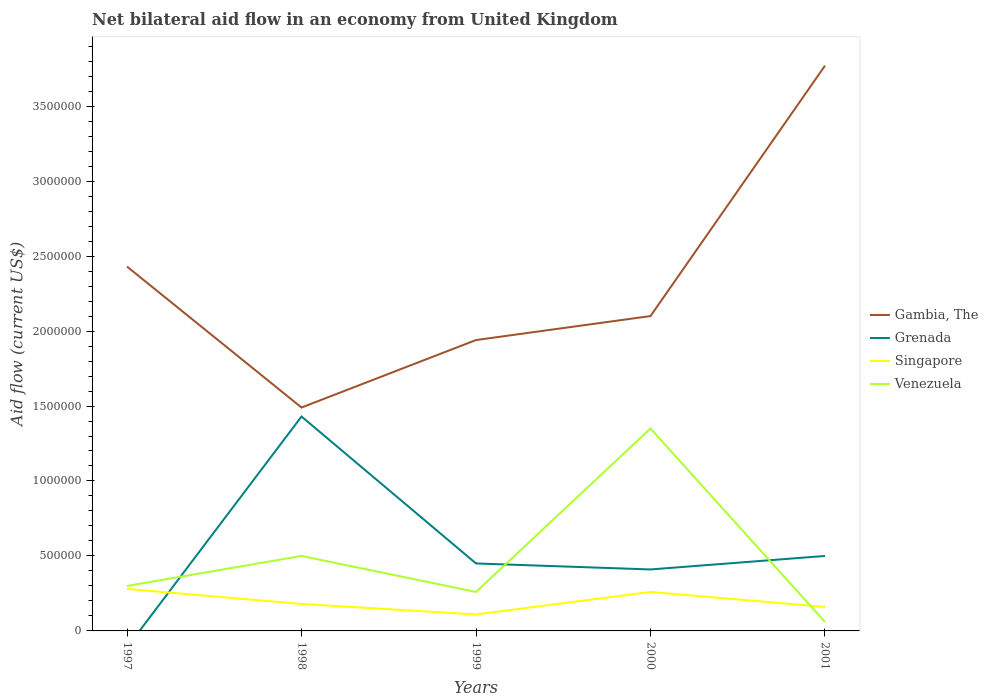Does the line corresponding to Singapore intersect with the line corresponding to Venezuela?
Your response must be concise. Yes. Is the number of lines equal to the number of legend labels?
Provide a short and direct response. No. What is the difference between the highest and the second highest net bilateral aid flow in Grenada?
Your response must be concise. 1.43e+06. Is the net bilateral aid flow in Grenada strictly greater than the net bilateral aid flow in Venezuela over the years?
Provide a short and direct response. No. How many lines are there?
Keep it short and to the point. 4. Does the graph contain any zero values?
Offer a very short reply. Yes. What is the title of the graph?
Offer a terse response. Net bilateral aid flow in an economy from United Kingdom. What is the label or title of the Y-axis?
Keep it short and to the point. Aid flow (current US$). What is the Aid flow (current US$) of Gambia, The in 1997?
Your answer should be very brief. 2.43e+06. What is the Aid flow (current US$) in Grenada in 1997?
Make the answer very short. 0. What is the Aid flow (current US$) in Venezuela in 1997?
Your answer should be very brief. 3.00e+05. What is the Aid flow (current US$) in Gambia, The in 1998?
Offer a very short reply. 1.49e+06. What is the Aid flow (current US$) in Grenada in 1998?
Provide a succinct answer. 1.43e+06. What is the Aid flow (current US$) of Gambia, The in 1999?
Your response must be concise. 1.94e+06. What is the Aid flow (current US$) of Singapore in 1999?
Offer a terse response. 1.10e+05. What is the Aid flow (current US$) in Venezuela in 1999?
Provide a short and direct response. 2.60e+05. What is the Aid flow (current US$) of Gambia, The in 2000?
Keep it short and to the point. 2.10e+06. What is the Aid flow (current US$) of Singapore in 2000?
Your answer should be compact. 2.60e+05. What is the Aid flow (current US$) of Venezuela in 2000?
Give a very brief answer. 1.35e+06. What is the Aid flow (current US$) of Gambia, The in 2001?
Make the answer very short. 3.77e+06. What is the Aid flow (current US$) of Singapore in 2001?
Offer a very short reply. 1.60e+05. Across all years, what is the maximum Aid flow (current US$) in Gambia, The?
Your response must be concise. 3.77e+06. Across all years, what is the maximum Aid flow (current US$) in Grenada?
Provide a short and direct response. 1.43e+06. Across all years, what is the maximum Aid flow (current US$) of Singapore?
Offer a terse response. 2.80e+05. Across all years, what is the maximum Aid flow (current US$) in Venezuela?
Ensure brevity in your answer.  1.35e+06. Across all years, what is the minimum Aid flow (current US$) in Gambia, The?
Your answer should be compact. 1.49e+06. Across all years, what is the minimum Aid flow (current US$) in Grenada?
Give a very brief answer. 0. Across all years, what is the minimum Aid flow (current US$) in Singapore?
Your answer should be compact. 1.10e+05. What is the total Aid flow (current US$) in Gambia, The in the graph?
Make the answer very short. 1.17e+07. What is the total Aid flow (current US$) in Grenada in the graph?
Keep it short and to the point. 2.79e+06. What is the total Aid flow (current US$) of Singapore in the graph?
Your answer should be very brief. 9.90e+05. What is the total Aid flow (current US$) of Venezuela in the graph?
Offer a terse response. 2.47e+06. What is the difference between the Aid flow (current US$) of Gambia, The in 1997 and that in 1998?
Your answer should be very brief. 9.40e+05. What is the difference between the Aid flow (current US$) in Gambia, The in 1997 and that in 1999?
Provide a short and direct response. 4.90e+05. What is the difference between the Aid flow (current US$) in Singapore in 1997 and that in 2000?
Make the answer very short. 2.00e+04. What is the difference between the Aid flow (current US$) of Venezuela in 1997 and that in 2000?
Offer a terse response. -1.05e+06. What is the difference between the Aid flow (current US$) of Gambia, The in 1997 and that in 2001?
Keep it short and to the point. -1.34e+06. What is the difference between the Aid flow (current US$) in Gambia, The in 1998 and that in 1999?
Keep it short and to the point. -4.50e+05. What is the difference between the Aid flow (current US$) in Grenada in 1998 and that in 1999?
Your answer should be compact. 9.80e+05. What is the difference between the Aid flow (current US$) of Singapore in 1998 and that in 1999?
Give a very brief answer. 7.00e+04. What is the difference between the Aid flow (current US$) in Gambia, The in 1998 and that in 2000?
Your response must be concise. -6.10e+05. What is the difference between the Aid flow (current US$) in Grenada in 1998 and that in 2000?
Provide a succinct answer. 1.02e+06. What is the difference between the Aid flow (current US$) in Singapore in 1998 and that in 2000?
Your answer should be compact. -8.00e+04. What is the difference between the Aid flow (current US$) in Venezuela in 1998 and that in 2000?
Ensure brevity in your answer.  -8.50e+05. What is the difference between the Aid flow (current US$) in Gambia, The in 1998 and that in 2001?
Give a very brief answer. -2.28e+06. What is the difference between the Aid flow (current US$) in Grenada in 1998 and that in 2001?
Provide a succinct answer. 9.30e+05. What is the difference between the Aid flow (current US$) of Venezuela in 1998 and that in 2001?
Give a very brief answer. 4.40e+05. What is the difference between the Aid flow (current US$) in Venezuela in 1999 and that in 2000?
Offer a terse response. -1.09e+06. What is the difference between the Aid flow (current US$) of Gambia, The in 1999 and that in 2001?
Offer a terse response. -1.83e+06. What is the difference between the Aid flow (current US$) in Venezuela in 1999 and that in 2001?
Make the answer very short. 2.00e+05. What is the difference between the Aid flow (current US$) of Gambia, The in 2000 and that in 2001?
Keep it short and to the point. -1.67e+06. What is the difference between the Aid flow (current US$) in Singapore in 2000 and that in 2001?
Ensure brevity in your answer.  1.00e+05. What is the difference between the Aid flow (current US$) in Venezuela in 2000 and that in 2001?
Offer a very short reply. 1.29e+06. What is the difference between the Aid flow (current US$) of Gambia, The in 1997 and the Aid flow (current US$) of Grenada in 1998?
Offer a terse response. 1.00e+06. What is the difference between the Aid flow (current US$) in Gambia, The in 1997 and the Aid flow (current US$) in Singapore in 1998?
Offer a terse response. 2.25e+06. What is the difference between the Aid flow (current US$) of Gambia, The in 1997 and the Aid flow (current US$) of Venezuela in 1998?
Keep it short and to the point. 1.93e+06. What is the difference between the Aid flow (current US$) in Gambia, The in 1997 and the Aid flow (current US$) in Grenada in 1999?
Your answer should be very brief. 1.98e+06. What is the difference between the Aid flow (current US$) of Gambia, The in 1997 and the Aid flow (current US$) of Singapore in 1999?
Offer a very short reply. 2.32e+06. What is the difference between the Aid flow (current US$) in Gambia, The in 1997 and the Aid flow (current US$) in Venezuela in 1999?
Your answer should be compact. 2.17e+06. What is the difference between the Aid flow (current US$) of Gambia, The in 1997 and the Aid flow (current US$) of Grenada in 2000?
Make the answer very short. 2.02e+06. What is the difference between the Aid flow (current US$) of Gambia, The in 1997 and the Aid flow (current US$) of Singapore in 2000?
Your response must be concise. 2.17e+06. What is the difference between the Aid flow (current US$) of Gambia, The in 1997 and the Aid flow (current US$) of Venezuela in 2000?
Offer a very short reply. 1.08e+06. What is the difference between the Aid flow (current US$) in Singapore in 1997 and the Aid flow (current US$) in Venezuela in 2000?
Your response must be concise. -1.07e+06. What is the difference between the Aid flow (current US$) in Gambia, The in 1997 and the Aid flow (current US$) in Grenada in 2001?
Ensure brevity in your answer.  1.93e+06. What is the difference between the Aid flow (current US$) of Gambia, The in 1997 and the Aid flow (current US$) of Singapore in 2001?
Offer a terse response. 2.27e+06. What is the difference between the Aid flow (current US$) of Gambia, The in 1997 and the Aid flow (current US$) of Venezuela in 2001?
Your answer should be compact. 2.37e+06. What is the difference between the Aid flow (current US$) in Singapore in 1997 and the Aid flow (current US$) in Venezuela in 2001?
Offer a terse response. 2.20e+05. What is the difference between the Aid flow (current US$) of Gambia, The in 1998 and the Aid flow (current US$) of Grenada in 1999?
Your response must be concise. 1.04e+06. What is the difference between the Aid flow (current US$) in Gambia, The in 1998 and the Aid flow (current US$) in Singapore in 1999?
Provide a succinct answer. 1.38e+06. What is the difference between the Aid flow (current US$) in Gambia, The in 1998 and the Aid flow (current US$) in Venezuela in 1999?
Your answer should be very brief. 1.23e+06. What is the difference between the Aid flow (current US$) in Grenada in 1998 and the Aid flow (current US$) in Singapore in 1999?
Provide a short and direct response. 1.32e+06. What is the difference between the Aid flow (current US$) in Grenada in 1998 and the Aid flow (current US$) in Venezuela in 1999?
Your answer should be compact. 1.17e+06. What is the difference between the Aid flow (current US$) of Singapore in 1998 and the Aid flow (current US$) of Venezuela in 1999?
Provide a short and direct response. -8.00e+04. What is the difference between the Aid flow (current US$) of Gambia, The in 1998 and the Aid flow (current US$) of Grenada in 2000?
Ensure brevity in your answer.  1.08e+06. What is the difference between the Aid flow (current US$) in Gambia, The in 1998 and the Aid flow (current US$) in Singapore in 2000?
Ensure brevity in your answer.  1.23e+06. What is the difference between the Aid flow (current US$) in Grenada in 1998 and the Aid flow (current US$) in Singapore in 2000?
Offer a terse response. 1.17e+06. What is the difference between the Aid flow (current US$) of Grenada in 1998 and the Aid flow (current US$) of Venezuela in 2000?
Offer a terse response. 8.00e+04. What is the difference between the Aid flow (current US$) of Singapore in 1998 and the Aid flow (current US$) of Venezuela in 2000?
Make the answer very short. -1.17e+06. What is the difference between the Aid flow (current US$) in Gambia, The in 1998 and the Aid flow (current US$) in Grenada in 2001?
Make the answer very short. 9.90e+05. What is the difference between the Aid flow (current US$) in Gambia, The in 1998 and the Aid flow (current US$) in Singapore in 2001?
Your answer should be compact. 1.33e+06. What is the difference between the Aid flow (current US$) in Gambia, The in 1998 and the Aid flow (current US$) in Venezuela in 2001?
Keep it short and to the point. 1.43e+06. What is the difference between the Aid flow (current US$) of Grenada in 1998 and the Aid flow (current US$) of Singapore in 2001?
Your response must be concise. 1.27e+06. What is the difference between the Aid flow (current US$) in Grenada in 1998 and the Aid flow (current US$) in Venezuela in 2001?
Make the answer very short. 1.37e+06. What is the difference between the Aid flow (current US$) of Gambia, The in 1999 and the Aid flow (current US$) of Grenada in 2000?
Your response must be concise. 1.53e+06. What is the difference between the Aid flow (current US$) of Gambia, The in 1999 and the Aid flow (current US$) of Singapore in 2000?
Provide a succinct answer. 1.68e+06. What is the difference between the Aid flow (current US$) in Gambia, The in 1999 and the Aid flow (current US$) in Venezuela in 2000?
Keep it short and to the point. 5.90e+05. What is the difference between the Aid flow (current US$) in Grenada in 1999 and the Aid flow (current US$) in Venezuela in 2000?
Offer a terse response. -9.00e+05. What is the difference between the Aid flow (current US$) of Singapore in 1999 and the Aid flow (current US$) of Venezuela in 2000?
Your answer should be compact. -1.24e+06. What is the difference between the Aid flow (current US$) of Gambia, The in 1999 and the Aid flow (current US$) of Grenada in 2001?
Your answer should be compact. 1.44e+06. What is the difference between the Aid flow (current US$) of Gambia, The in 1999 and the Aid flow (current US$) of Singapore in 2001?
Provide a succinct answer. 1.78e+06. What is the difference between the Aid flow (current US$) of Gambia, The in 1999 and the Aid flow (current US$) of Venezuela in 2001?
Your answer should be very brief. 1.88e+06. What is the difference between the Aid flow (current US$) in Grenada in 1999 and the Aid flow (current US$) in Singapore in 2001?
Give a very brief answer. 2.90e+05. What is the difference between the Aid flow (current US$) in Grenada in 1999 and the Aid flow (current US$) in Venezuela in 2001?
Provide a succinct answer. 3.90e+05. What is the difference between the Aid flow (current US$) in Gambia, The in 2000 and the Aid flow (current US$) in Grenada in 2001?
Give a very brief answer. 1.60e+06. What is the difference between the Aid flow (current US$) of Gambia, The in 2000 and the Aid flow (current US$) of Singapore in 2001?
Ensure brevity in your answer.  1.94e+06. What is the difference between the Aid flow (current US$) of Gambia, The in 2000 and the Aid flow (current US$) of Venezuela in 2001?
Give a very brief answer. 2.04e+06. What is the difference between the Aid flow (current US$) in Grenada in 2000 and the Aid flow (current US$) in Venezuela in 2001?
Provide a succinct answer. 3.50e+05. What is the difference between the Aid flow (current US$) of Singapore in 2000 and the Aid flow (current US$) of Venezuela in 2001?
Keep it short and to the point. 2.00e+05. What is the average Aid flow (current US$) of Gambia, The per year?
Your answer should be compact. 2.35e+06. What is the average Aid flow (current US$) in Grenada per year?
Keep it short and to the point. 5.58e+05. What is the average Aid flow (current US$) of Singapore per year?
Provide a short and direct response. 1.98e+05. What is the average Aid flow (current US$) of Venezuela per year?
Keep it short and to the point. 4.94e+05. In the year 1997, what is the difference between the Aid flow (current US$) in Gambia, The and Aid flow (current US$) in Singapore?
Offer a very short reply. 2.15e+06. In the year 1997, what is the difference between the Aid flow (current US$) in Gambia, The and Aid flow (current US$) in Venezuela?
Make the answer very short. 2.13e+06. In the year 1998, what is the difference between the Aid flow (current US$) in Gambia, The and Aid flow (current US$) in Grenada?
Keep it short and to the point. 6.00e+04. In the year 1998, what is the difference between the Aid flow (current US$) in Gambia, The and Aid flow (current US$) in Singapore?
Offer a terse response. 1.31e+06. In the year 1998, what is the difference between the Aid flow (current US$) in Gambia, The and Aid flow (current US$) in Venezuela?
Make the answer very short. 9.90e+05. In the year 1998, what is the difference between the Aid flow (current US$) in Grenada and Aid flow (current US$) in Singapore?
Ensure brevity in your answer.  1.25e+06. In the year 1998, what is the difference between the Aid flow (current US$) in Grenada and Aid flow (current US$) in Venezuela?
Your answer should be very brief. 9.30e+05. In the year 1998, what is the difference between the Aid flow (current US$) in Singapore and Aid flow (current US$) in Venezuela?
Provide a succinct answer. -3.20e+05. In the year 1999, what is the difference between the Aid flow (current US$) in Gambia, The and Aid flow (current US$) in Grenada?
Offer a terse response. 1.49e+06. In the year 1999, what is the difference between the Aid flow (current US$) of Gambia, The and Aid flow (current US$) of Singapore?
Provide a succinct answer. 1.83e+06. In the year 1999, what is the difference between the Aid flow (current US$) of Gambia, The and Aid flow (current US$) of Venezuela?
Your answer should be very brief. 1.68e+06. In the year 1999, what is the difference between the Aid flow (current US$) of Grenada and Aid flow (current US$) of Singapore?
Offer a very short reply. 3.40e+05. In the year 1999, what is the difference between the Aid flow (current US$) in Grenada and Aid flow (current US$) in Venezuela?
Provide a short and direct response. 1.90e+05. In the year 2000, what is the difference between the Aid flow (current US$) of Gambia, The and Aid flow (current US$) of Grenada?
Keep it short and to the point. 1.69e+06. In the year 2000, what is the difference between the Aid flow (current US$) of Gambia, The and Aid flow (current US$) of Singapore?
Give a very brief answer. 1.84e+06. In the year 2000, what is the difference between the Aid flow (current US$) of Gambia, The and Aid flow (current US$) of Venezuela?
Provide a succinct answer. 7.50e+05. In the year 2000, what is the difference between the Aid flow (current US$) of Grenada and Aid flow (current US$) of Venezuela?
Give a very brief answer. -9.40e+05. In the year 2000, what is the difference between the Aid flow (current US$) in Singapore and Aid flow (current US$) in Venezuela?
Offer a terse response. -1.09e+06. In the year 2001, what is the difference between the Aid flow (current US$) of Gambia, The and Aid flow (current US$) of Grenada?
Give a very brief answer. 3.27e+06. In the year 2001, what is the difference between the Aid flow (current US$) of Gambia, The and Aid flow (current US$) of Singapore?
Keep it short and to the point. 3.61e+06. In the year 2001, what is the difference between the Aid flow (current US$) of Gambia, The and Aid flow (current US$) of Venezuela?
Ensure brevity in your answer.  3.71e+06. In the year 2001, what is the difference between the Aid flow (current US$) in Singapore and Aid flow (current US$) in Venezuela?
Your answer should be very brief. 1.00e+05. What is the ratio of the Aid flow (current US$) of Gambia, The in 1997 to that in 1998?
Offer a terse response. 1.63. What is the ratio of the Aid flow (current US$) in Singapore in 1997 to that in 1998?
Give a very brief answer. 1.56. What is the ratio of the Aid flow (current US$) in Venezuela in 1997 to that in 1998?
Provide a succinct answer. 0.6. What is the ratio of the Aid flow (current US$) of Gambia, The in 1997 to that in 1999?
Give a very brief answer. 1.25. What is the ratio of the Aid flow (current US$) in Singapore in 1997 to that in 1999?
Your answer should be compact. 2.55. What is the ratio of the Aid flow (current US$) of Venezuela in 1997 to that in 1999?
Make the answer very short. 1.15. What is the ratio of the Aid flow (current US$) of Gambia, The in 1997 to that in 2000?
Provide a succinct answer. 1.16. What is the ratio of the Aid flow (current US$) of Venezuela in 1997 to that in 2000?
Your response must be concise. 0.22. What is the ratio of the Aid flow (current US$) in Gambia, The in 1997 to that in 2001?
Provide a succinct answer. 0.64. What is the ratio of the Aid flow (current US$) in Singapore in 1997 to that in 2001?
Your answer should be compact. 1.75. What is the ratio of the Aid flow (current US$) in Gambia, The in 1998 to that in 1999?
Make the answer very short. 0.77. What is the ratio of the Aid flow (current US$) of Grenada in 1998 to that in 1999?
Your answer should be compact. 3.18. What is the ratio of the Aid flow (current US$) of Singapore in 1998 to that in 1999?
Give a very brief answer. 1.64. What is the ratio of the Aid flow (current US$) of Venezuela in 1998 to that in 1999?
Provide a succinct answer. 1.92. What is the ratio of the Aid flow (current US$) of Gambia, The in 1998 to that in 2000?
Give a very brief answer. 0.71. What is the ratio of the Aid flow (current US$) of Grenada in 1998 to that in 2000?
Your answer should be compact. 3.49. What is the ratio of the Aid flow (current US$) in Singapore in 1998 to that in 2000?
Your response must be concise. 0.69. What is the ratio of the Aid flow (current US$) in Venezuela in 1998 to that in 2000?
Your answer should be compact. 0.37. What is the ratio of the Aid flow (current US$) in Gambia, The in 1998 to that in 2001?
Give a very brief answer. 0.4. What is the ratio of the Aid flow (current US$) of Grenada in 1998 to that in 2001?
Give a very brief answer. 2.86. What is the ratio of the Aid flow (current US$) in Venezuela in 1998 to that in 2001?
Your answer should be compact. 8.33. What is the ratio of the Aid flow (current US$) in Gambia, The in 1999 to that in 2000?
Provide a succinct answer. 0.92. What is the ratio of the Aid flow (current US$) of Grenada in 1999 to that in 2000?
Your response must be concise. 1.1. What is the ratio of the Aid flow (current US$) of Singapore in 1999 to that in 2000?
Provide a short and direct response. 0.42. What is the ratio of the Aid flow (current US$) in Venezuela in 1999 to that in 2000?
Keep it short and to the point. 0.19. What is the ratio of the Aid flow (current US$) of Gambia, The in 1999 to that in 2001?
Provide a short and direct response. 0.51. What is the ratio of the Aid flow (current US$) in Singapore in 1999 to that in 2001?
Ensure brevity in your answer.  0.69. What is the ratio of the Aid flow (current US$) of Venezuela in 1999 to that in 2001?
Keep it short and to the point. 4.33. What is the ratio of the Aid flow (current US$) in Gambia, The in 2000 to that in 2001?
Your answer should be very brief. 0.56. What is the ratio of the Aid flow (current US$) of Grenada in 2000 to that in 2001?
Give a very brief answer. 0.82. What is the ratio of the Aid flow (current US$) of Singapore in 2000 to that in 2001?
Ensure brevity in your answer.  1.62. What is the ratio of the Aid flow (current US$) in Venezuela in 2000 to that in 2001?
Give a very brief answer. 22.5. What is the difference between the highest and the second highest Aid flow (current US$) of Gambia, The?
Keep it short and to the point. 1.34e+06. What is the difference between the highest and the second highest Aid flow (current US$) in Grenada?
Your answer should be very brief. 9.30e+05. What is the difference between the highest and the second highest Aid flow (current US$) in Singapore?
Offer a terse response. 2.00e+04. What is the difference between the highest and the second highest Aid flow (current US$) of Venezuela?
Ensure brevity in your answer.  8.50e+05. What is the difference between the highest and the lowest Aid flow (current US$) of Gambia, The?
Offer a very short reply. 2.28e+06. What is the difference between the highest and the lowest Aid flow (current US$) of Grenada?
Provide a short and direct response. 1.43e+06. What is the difference between the highest and the lowest Aid flow (current US$) in Singapore?
Your response must be concise. 1.70e+05. What is the difference between the highest and the lowest Aid flow (current US$) in Venezuela?
Give a very brief answer. 1.29e+06. 